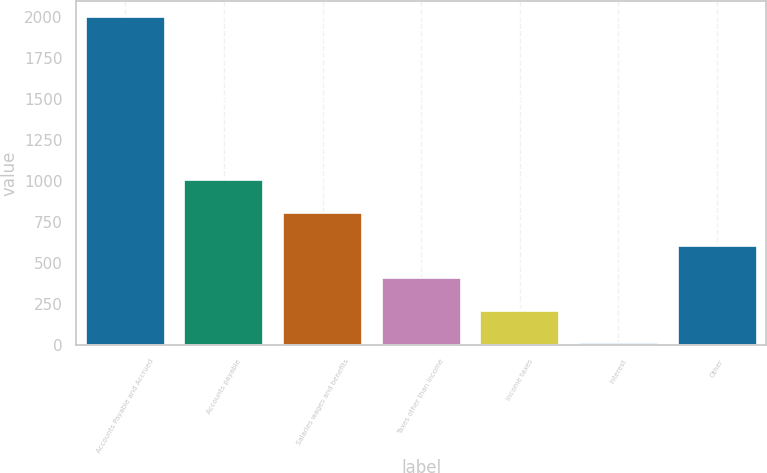Convert chart. <chart><loc_0><loc_0><loc_500><loc_500><bar_chart><fcel>Accounts Payable and Accrued<fcel>Accounts payable<fcel>Salaries wages and benefits<fcel>Taxes other than income<fcel>Income taxes<fcel>Interest<fcel>Other<nl><fcel>2001<fcel>1004.6<fcel>805.32<fcel>406.76<fcel>207.48<fcel>8.2<fcel>606.04<nl></chart> 